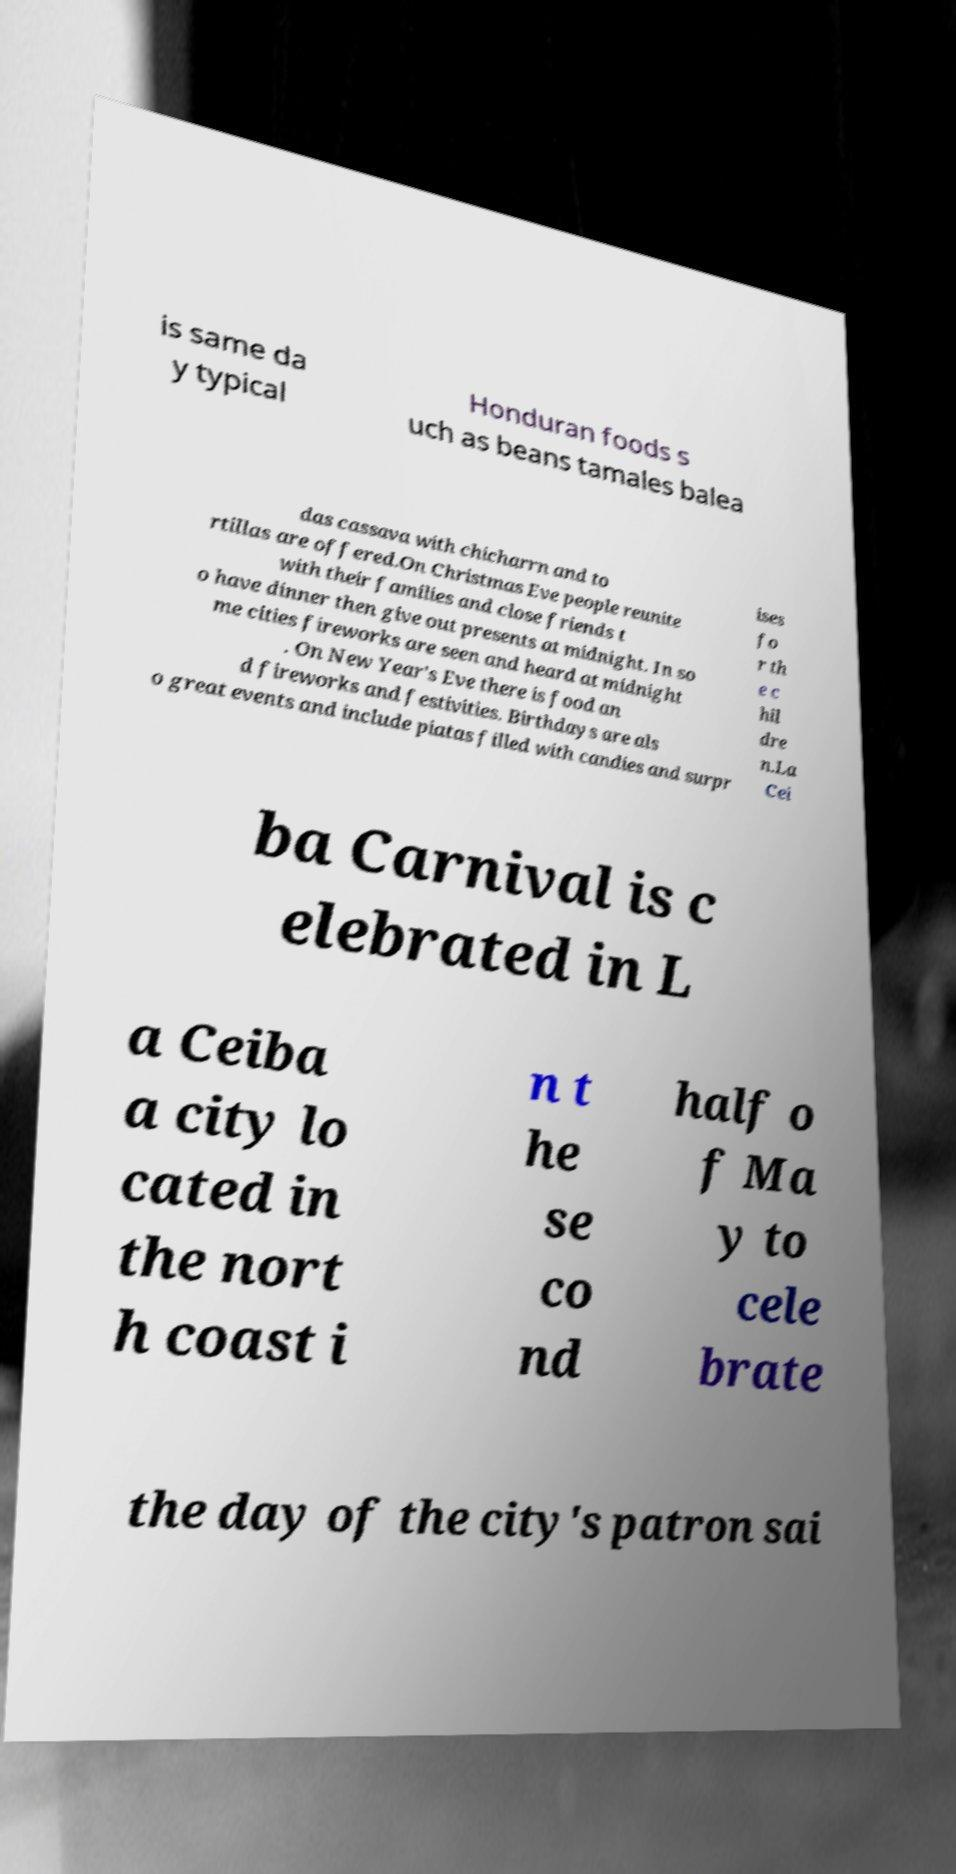Please read and relay the text visible in this image. What does it say? is same da y typical Honduran foods s uch as beans tamales balea das cassava with chicharrn and to rtillas are offered.On Christmas Eve people reunite with their families and close friends t o have dinner then give out presents at midnight. In so me cities fireworks are seen and heard at midnight . On New Year's Eve there is food an d fireworks and festivities. Birthdays are als o great events and include piatas filled with candies and surpr ises fo r th e c hil dre n.La Cei ba Carnival is c elebrated in L a Ceiba a city lo cated in the nort h coast i n t he se co nd half o f Ma y to cele brate the day of the city's patron sai 